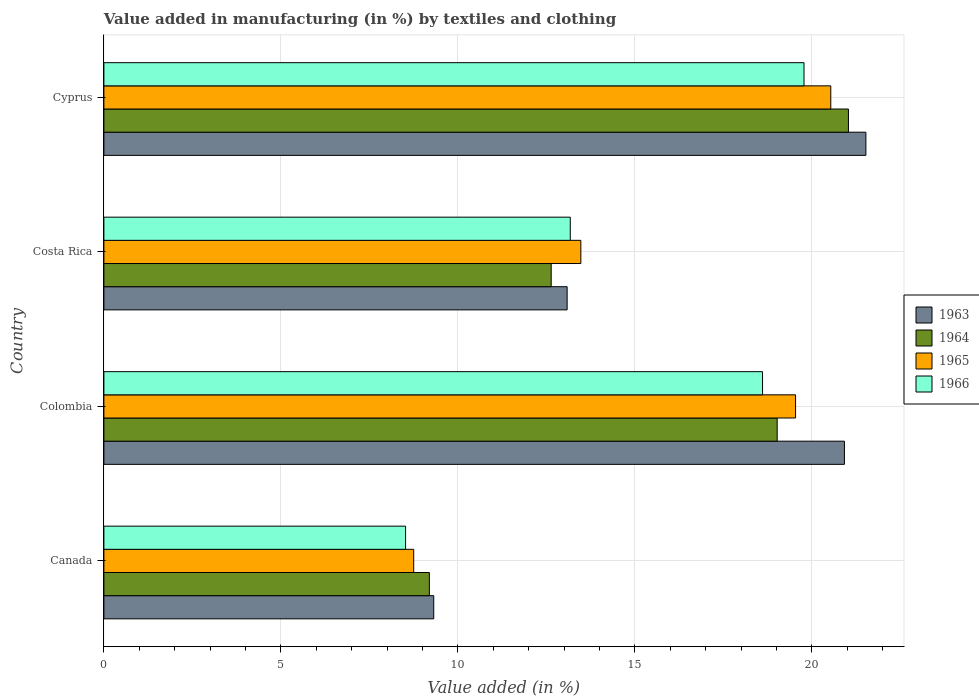How many bars are there on the 2nd tick from the top?
Offer a terse response. 4. How many bars are there on the 3rd tick from the bottom?
Offer a terse response. 4. What is the label of the 2nd group of bars from the top?
Offer a terse response. Costa Rica. What is the percentage of value added in manufacturing by textiles and clothing in 1963 in Costa Rica?
Provide a succinct answer. 13.08. Across all countries, what is the maximum percentage of value added in manufacturing by textiles and clothing in 1966?
Offer a very short reply. 19.78. Across all countries, what is the minimum percentage of value added in manufacturing by textiles and clothing in 1965?
Give a very brief answer. 8.75. In which country was the percentage of value added in manufacturing by textiles and clothing in 1963 maximum?
Your response must be concise. Cyprus. What is the total percentage of value added in manufacturing by textiles and clothing in 1965 in the graph?
Keep it short and to the point. 62.29. What is the difference between the percentage of value added in manufacturing by textiles and clothing in 1964 in Canada and that in Cyprus?
Keep it short and to the point. -11.84. What is the difference between the percentage of value added in manufacturing by textiles and clothing in 1963 in Colombia and the percentage of value added in manufacturing by textiles and clothing in 1964 in Cyprus?
Ensure brevity in your answer.  -0.11. What is the average percentage of value added in manufacturing by textiles and clothing in 1964 per country?
Provide a short and direct response. 15.47. What is the difference between the percentage of value added in manufacturing by textiles and clothing in 1963 and percentage of value added in manufacturing by textiles and clothing in 1964 in Canada?
Make the answer very short. 0.12. What is the ratio of the percentage of value added in manufacturing by textiles and clothing in 1965 in Canada to that in Costa Rica?
Offer a very short reply. 0.65. Is the difference between the percentage of value added in manufacturing by textiles and clothing in 1963 in Canada and Cyprus greater than the difference between the percentage of value added in manufacturing by textiles and clothing in 1964 in Canada and Cyprus?
Provide a short and direct response. No. What is the difference between the highest and the second highest percentage of value added in manufacturing by textiles and clothing in 1964?
Give a very brief answer. 2.01. What is the difference between the highest and the lowest percentage of value added in manufacturing by textiles and clothing in 1965?
Make the answer very short. 11.78. Is the sum of the percentage of value added in manufacturing by textiles and clothing in 1966 in Canada and Cyprus greater than the maximum percentage of value added in manufacturing by textiles and clothing in 1965 across all countries?
Your answer should be very brief. Yes. Is it the case that in every country, the sum of the percentage of value added in manufacturing by textiles and clothing in 1963 and percentage of value added in manufacturing by textiles and clothing in 1964 is greater than the sum of percentage of value added in manufacturing by textiles and clothing in 1965 and percentage of value added in manufacturing by textiles and clothing in 1966?
Your response must be concise. No. What does the 4th bar from the top in Canada represents?
Make the answer very short. 1963. What does the 2nd bar from the bottom in Cyprus represents?
Offer a very short reply. 1964. Are all the bars in the graph horizontal?
Make the answer very short. Yes. How many countries are there in the graph?
Give a very brief answer. 4. What is the difference between two consecutive major ticks on the X-axis?
Keep it short and to the point. 5. Where does the legend appear in the graph?
Your response must be concise. Center right. How many legend labels are there?
Make the answer very short. 4. What is the title of the graph?
Provide a succinct answer. Value added in manufacturing (in %) by textiles and clothing. What is the label or title of the X-axis?
Your answer should be very brief. Value added (in %). What is the Value added (in %) in 1963 in Canada?
Ensure brevity in your answer.  9.32. What is the Value added (in %) in 1964 in Canada?
Ensure brevity in your answer.  9.19. What is the Value added (in %) of 1965 in Canada?
Your answer should be compact. 8.75. What is the Value added (in %) of 1966 in Canada?
Your answer should be very brief. 8.52. What is the Value added (in %) in 1963 in Colombia?
Provide a succinct answer. 20.92. What is the Value added (in %) of 1964 in Colombia?
Give a very brief answer. 19.02. What is the Value added (in %) of 1965 in Colombia?
Provide a short and direct response. 19.54. What is the Value added (in %) of 1966 in Colombia?
Offer a very short reply. 18.6. What is the Value added (in %) of 1963 in Costa Rica?
Provide a succinct answer. 13.08. What is the Value added (in %) in 1964 in Costa Rica?
Provide a short and direct response. 12.63. What is the Value added (in %) of 1965 in Costa Rica?
Offer a terse response. 13.47. What is the Value added (in %) of 1966 in Costa Rica?
Make the answer very short. 13.17. What is the Value added (in %) in 1963 in Cyprus?
Provide a short and direct response. 21.52. What is the Value added (in %) of 1964 in Cyprus?
Your response must be concise. 21.03. What is the Value added (in %) of 1965 in Cyprus?
Give a very brief answer. 20.53. What is the Value added (in %) of 1966 in Cyprus?
Offer a very short reply. 19.78. Across all countries, what is the maximum Value added (in %) in 1963?
Your response must be concise. 21.52. Across all countries, what is the maximum Value added (in %) in 1964?
Provide a short and direct response. 21.03. Across all countries, what is the maximum Value added (in %) in 1965?
Make the answer very short. 20.53. Across all countries, what is the maximum Value added (in %) of 1966?
Make the answer very short. 19.78. Across all countries, what is the minimum Value added (in %) in 1963?
Your answer should be very brief. 9.32. Across all countries, what is the minimum Value added (in %) in 1964?
Offer a very short reply. 9.19. Across all countries, what is the minimum Value added (in %) in 1965?
Offer a very short reply. 8.75. Across all countries, what is the minimum Value added (in %) in 1966?
Keep it short and to the point. 8.52. What is the total Value added (in %) in 1963 in the graph?
Provide a short and direct response. 64.84. What is the total Value added (in %) in 1964 in the graph?
Keep it short and to the point. 61.88. What is the total Value added (in %) in 1965 in the graph?
Make the answer very short. 62.29. What is the total Value added (in %) of 1966 in the graph?
Your answer should be compact. 60.08. What is the difference between the Value added (in %) in 1963 in Canada and that in Colombia?
Offer a very short reply. -11.6. What is the difference between the Value added (in %) of 1964 in Canada and that in Colombia?
Ensure brevity in your answer.  -9.82. What is the difference between the Value added (in %) in 1965 in Canada and that in Colombia?
Your answer should be very brief. -10.79. What is the difference between the Value added (in %) in 1966 in Canada and that in Colombia?
Your answer should be compact. -10.08. What is the difference between the Value added (in %) of 1963 in Canada and that in Costa Rica?
Keep it short and to the point. -3.77. What is the difference between the Value added (in %) of 1964 in Canada and that in Costa Rica?
Give a very brief answer. -3.44. What is the difference between the Value added (in %) of 1965 in Canada and that in Costa Rica?
Your answer should be very brief. -4.72. What is the difference between the Value added (in %) in 1966 in Canada and that in Costa Rica?
Your answer should be very brief. -4.65. What is the difference between the Value added (in %) in 1963 in Canada and that in Cyprus?
Your response must be concise. -12.21. What is the difference between the Value added (in %) in 1964 in Canada and that in Cyprus?
Ensure brevity in your answer.  -11.84. What is the difference between the Value added (in %) of 1965 in Canada and that in Cyprus?
Your answer should be very brief. -11.78. What is the difference between the Value added (in %) of 1966 in Canada and that in Cyprus?
Make the answer very short. -11.25. What is the difference between the Value added (in %) of 1963 in Colombia and that in Costa Rica?
Make the answer very short. 7.83. What is the difference between the Value added (in %) in 1964 in Colombia and that in Costa Rica?
Keep it short and to the point. 6.38. What is the difference between the Value added (in %) of 1965 in Colombia and that in Costa Rica?
Provide a short and direct response. 6.06. What is the difference between the Value added (in %) of 1966 in Colombia and that in Costa Rica?
Ensure brevity in your answer.  5.43. What is the difference between the Value added (in %) of 1963 in Colombia and that in Cyprus?
Provide a short and direct response. -0.61. What is the difference between the Value added (in %) in 1964 in Colombia and that in Cyprus?
Your response must be concise. -2.01. What is the difference between the Value added (in %) in 1965 in Colombia and that in Cyprus?
Ensure brevity in your answer.  -0.99. What is the difference between the Value added (in %) of 1966 in Colombia and that in Cyprus?
Your response must be concise. -1.17. What is the difference between the Value added (in %) of 1963 in Costa Rica and that in Cyprus?
Your answer should be very brief. -8.44. What is the difference between the Value added (in %) in 1964 in Costa Rica and that in Cyprus?
Offer a terse response. -8.4. What is the difference between the Value added (in %) of 1965 in Costa Rica and that in Cyprus?
Your response must be concise. -7.06. What is the difference between the Value added (in %) in 1966 in Costa Rica and that in Cyprus?
Provide a short and direct response. -6.6. What is the difference between the Value added (in %) in 1963 in Canada and the Value added (in %) in 1964 in Colombia?
Give a very brief answer. -9.7. What is the difference between the Value added (in %) in 1963 in Canada and the Value added (in %) in 1965 in Colombia?
Provide a succinct answer. -10.22. What is the difference between the Value added (in %) in 1963 in Canada and the Value added (in %) in 1966 in Colombia?
Your answer should be very brief. -9.29. What is the difference between the Value added (in %) in 1964 in Canada and the Value added (in %) in 1965 in Colombia?
Make the answer very short. -10.34. What is the difference between the Value added (in %) of 1964 in Canada and the Value added (in %) of 1966 in Colombia?
Your answer should be compact. -9.41. What is the difference between the Value added (in %) of 1965 in Canada and the Value added (in %) of 1966 in Colombia?
Your answer should be very brief. -9.85. What is the difference between the Value added (in %) of 1963 in Canada and the Value added (in %) of 1964 in Costa Rica?
Your answer should be compact. -3.32. What is the difference between the Value added (in %) in 1963 in Canada and the Value added (in %) in 1965 in Costa Rica?
Your answer should be very brief. -4.16. What is the difference between the Value added (in %) of 1963 in Canada and the Value added (in %) of 1966 in Costa Rica?
Offer a terse response. -3.86. What is the difference between the Value added (in %) of 1964 in Canada and the Value added (in %) of 1965 in Costa Rica?
Offer a terse response. -4.28. What is the difference between the Value added (in %) in 1964 in Canada and the Value added (in %) in 1966 in Costa Rica?
Give a very brief answer. -3.98. What is the difference between the Value added (in %) in 1965 in Canada and the Value added (in %) in 1966 in Costa Rica?
Offer a very short reply. -4.42. What is the difference between the Value added (in %) of 1963 in Canada and the Value added (in %) of 1964 in Cyprus?
Give a very brief answer. -11.71. What is the difference between the Value added (in %) in 1963 in Canada and the Value added (in %) in 1965 in Cyprus?
Ensure brevity in your answer.  -11.21. What is the difference between the Value added (in %) of 1963 in Canada and the Value added (in %) of 1966 in Cyprus?
Your answer should be very brief. -10.46. What is the difference between the Value added (in %) of 1964 in Canada and the Value added (in %) of 1965 in Cyprus?
Your response must be concise. -11.34. What is the difference between the Value added (in %) in 1964 in Canada and the Value added (in %) in 1966 in Cyprus?
Offer a very short reply. -10.58. What is the difference between the Value added (in %) of 1965 in Canada and the Value added (in %) of 1966 in Cyprus?
Offer a very short reply. -11.02. What is the difference between the Value added (in %) of 1963 in Colombia and the Value added (in %) of 1964 in Costa Rica?
Your answer should be compact. 8.28. What is the difference between the Value added (in %) in 1963 in Colombia and the Value added (in %) in 1965 in Costa Rica?
Your response must be concise. 7.44. What is the difference between the Value added (in %) of 1963 in Colombia and the Value added (in %) of 1966 in Costa Rica?
Provide a succinct answer. 7.74. What is the difference between the Value added (in %) of 1964 in Colombia and the Value added (in %) of 1965 in Costa Rica?
Make the answer very short. 5.55. What is the difference between the Value added (in %) in 1964 in Colombia and the Value added (in %) in 1966 in Costa Rica?
Provide a succinct answer. 5.84. What is the difference between the Value added (in %) in 1965 in Colombia and the Value added (in %) in 1966 in Costa Rica?
Provide a succinct answer. 6.36. What is the difference between the Value added (in %) of 1963 in Colombia and the Value added (in %) of 1964 in Cyprus?
Offer a terse response. -0.11. What is the difference between the Value added (in %) of 1963 in Colombia and the Value added (in %) of 1965 in Cyprus?
Offer a terse response. 0.39. What is the difference between the Value added (in %) of 1963 in Colombia and the Value added (in %) of 1966 in Cyprus?
Your answer should be very brief. 1.14. What is the difference between the Value added (in %) of 1964 in Colombia and the Value added (in %) of 1965 in Cyprus?
Make the answer very short. -1.51. What is the difference between the Value added (in %) of 1964 in Colombia and the Value added (in %) of 1966 in Cyprus?
Provide a short and direct response. -0.76. What is the difference between the Value added (in %) in 1965 in Colombia and the Value added (in %) in 1966 in Cyprus?
Give a very brief answer. -0.24. What is the difference between the Value added (in %) in 1963 in Costa Rica and the Value added (in %) in 1964 in Cyprus?
Your answer should be compact. -7.95. What is the difference between the Value added (in %) of 1963 in Costa Rica and the Value added (in %) of 1965 in Cyprus?
Make the answer very short. -7.45. What is the difference between the Value added (in %) in 1963 in Costa Rica and the Value added (in %) in 1966 in Cyprus?
Make the answer very short. -6.69. What is the difference between the Value added (in %) of 1964 in Costa Rica and the Value added (in %) of 1965 in Cyprus?
Give a very brief answer. -7.9. What is the difference between the Value added (in %) in 1964 in Costa Rica and the Value added (in %) in 1966 in Cyprus?
Your response must be concise. -7.14. What is the difference between the Value added (in %) in 1965 in Costa Rica and the Value added (in %) in 1966 in Cyprus?
Your response must be concise. -6.3. What is the average Value added (in %) of 1963 per country?
Your answer should be very brief. 16.21. What is the average Value added (in %) in 1964 per country?
Make the answer very short. 15.47. What is the average Value added (in %) of 1965 per country?
Your answer should be compact. 15.57. What is the average Value added (in %) of 1966 per country?
Keep it short and to the point. 15.02. What is the difference between the Value added (in %) of 1963 and Value added (in %) of 1964 in Canada?
Your answer should be very brief. 0.12. What is the difference between the Value added (in %) of 1963 and Value added (in %) of 1965 in Canada?
Provide a short and direct response. 0.57. What is the difference between the Value added (in %) of 1963 and Value added (in %) of 1966 in Canada?
Ensure brevity in your answer.  0.8. What is the difference between the Value added (in %) in 1964 and Value added (in %) in 1965 in Canada?
Give a very brief answer. 0.44. What is the difference between the Value added (in %) of 1964 and Value added (in %) of 1966 in Canada?
Your response must be concise. 0.67. What is the difference between the Value added (in %) of 1965 and Value added (in %) of 1966 in Canada?
Give a very brief answer. 0.23. What is the difference between the Value added (in %) in 1963 and Value added (in %) in 1964 in Colombia?
Your answer should be very brief. 1.9. What is the difference between the Value added (in %) in 1963 and Value added (in %) in 1965 in Colombia?
Make the answer very short. 1.38. What is the difference between the Value added (in %) of 1963 and Value added (in %) of 1966 in Colombia?
Ensure brevity in your answer.  2.31. What is the difference between the Value added (in %) of 1964 and Value added (in %) of 1965 in Colombia?
Provide a succinct answer. -0.52. What is the difference between the Value added (in %) of 1964 and Value added (in %) of 1966 in Colombia?
Your response must be concise. 0.41. What is the difference between the Value added (in %) of 1965 and Value added (in %) of 1966 in Colombia?
Make the answer very short. 0.93. What is the difference between the Value added (in %) of 1963 and Value added (in %) of 1964 in Costa Rica?
Offer a very short reply. 0.45. What is the difference between the Value added (in %) in 1963 and Value added (in %) in 1965 in Costa Rica?
Offer a very short reply. -0.39. What is the difference between the Value added (in %) in 1963 and Value added (in %) in 1966 in Costa Rica?
Offer a very short reply. -0.09. What is the difference between the Value added (in %) in 1964 and Value added (in %) in 1965 in Costa Rica?
Ensure brevity in your answer.  -0.84. What is the difference between the Value added (in %) in 1964 and Value added (in %) in 1966 in Costa Rica?
Offer a very short reply. -0.54. What is the difference between the Value added (in %) of 1965 and Value added (in %) of 1966 in Costa Rica?
Make the answer very short. 0.3. What is the difference between the Value added (in %) of 1963 and Value added (in %) of 1964 in Cyprus?
Offer a terse response. 0.49. What is the difference between the Value added (in %) of 1963 and Value added (in %) of 1965 in Cyprus?
Your answer should be very brief. 0.99. What is the difference between the Value added (in %) of 1963 and Value added (in %) of 1966 in Cyprus?
Offer a terse response. 1.75. What is the difference between the Value added (in %) in 1964 and Value added (in %) in 1965 in Cyprus?
Provide a short and direct response. 0.5. What is the difference between the Value added (in %) of 1964 and Value added (in %) of 1966 in Cyprus?
Offer a terse response. 1.25. What is the difference between the Value added (in %) of 1965 and Value added (in %) of 1966 in Cyprus?
Offer a terse response. 0.76. What is the ratio of the Value added (in %) in 1963 in Canada to that in Colombia?
Provide a succinct answer. 0.45. What is the ratio of the Value added (in %) in 1964 in Canada to that in Colombia?
Provide a short and direct response. 0.48. What is the ratio of the Value added (in %) in 1965 in Canada to that in Colombia?
Offer a very short reply. 0.45. What is the ratio of the Value added (in %) in 1966 in Canada to that in Colombia?
Ensure brevity in your answer.  0.46. What is the ratio of the Value added (in %) of 1963 in Canada to that in Costa Rica?
Keep it short and to the point. 0.71. What is the ratio of the Value added (in %) in 1964 in Canada to that in Costa Rica?
Give a very brief answer. 0.73. What is the ratio of the Value added (in %) of 1965 in Canada to that in Costa Rica?
Make the answer very short. 0.65. What is the ratio of the Value added (in %) of 1966 in Canada to that in Costa Rica?
Ensure brevity in your answer.  0.65. What is the ratio of the Value added (in %) of 1963 in Canada to that in Cyprus?
Ensure brevity in your answer.  0.43. What is the ratio of the Value added (in %) of 1964 in Canada to that in Cyprus?
Provide a succinct answer. 0.44. What is the ratio of the Value added (in %) of 1965 in Canada to that in Cyprus?
Your answer should be very brief. 0.43. What is the ratio of the Value added (in %) in 1966 in Canada to that in Cyprus?
Keep it short and to the point. 0.43. What is the ratio of the Value added (in %) in 1963 in Colombia to that in Costa Rica?
Your answer should be compact. 1.6. What is the ratio of the Value added (in %) in 1964 in Colombia to that in Costa Rica?
Offer a very short reply. 1.51. What is the ratio of the Value added (in %) in 1965 in Colombia to that in Costa Rica?
Give a very brief answer. 1.45. What is the ratio of the Value added (in %) in 1966 in Colombia to that in Costa Rica?
Offer a terse response. 1.41. What is the ratio of the Value added (in %) of 1963 in Colombia to that in Cyprus?
Make the answer very short. 0.97. What is the ratio of the Value added (in %) in 1964 in Colombia to that in Cyprus?
Provide a succinct answer. 0.9. What is the ratio of the Value added (in %) in 1965 in Colombia to that in Cyprus?
Your response must be concise. 0.95. What is the ratio of the Value added (in %) in 1966 in Colombia to that in Cyprus?
Your response must be concise. 0.94. What is the ratio of the Value added (in %) of 1963 in Costa Rica to that in Cyprus?
Offer a very short reply. 0.61. What is the ratio of the Value added (in %) of 1964 in Costa Rica to that in Cyprus?
Ensure brevity in your answer.  0.6. What is the ratio of the Value added (in %) in 1965 in Costa Rica to that in Cyprus?
Give a very brief answer. 0.66. What is the ratio of the Value added (in %) in 1966 in Costa Rica to that in Cyprus?
Offer a very short reply. 0.67. What is the difference between the highest and the second highest Value added (in %) in 1963?
Make the answer very short. 0.61. What is the difference between the highest and the second highest Value added (in %) of 1964?
Provide a short and direct response. 2.01. What is the difference between the highest and the second highest Value added (in %) in 1966?
Offer a terse response. 1.17. What is the difference between the highest and the lowest Value added (in %) of 1963?
Your answer should be very brief. 12.21. What is the difference between the highest and the lowest Value added (in %) of 1964?
Keep it short and to the point. 11.84. What is the difference between the highest and the lowest Value added (in %) of 1965?
Your response must be concise. 11.78. What is the difference between the highest and the lowest Value added (in %) of 1966?
Your answer should be very brief. 11.25. 